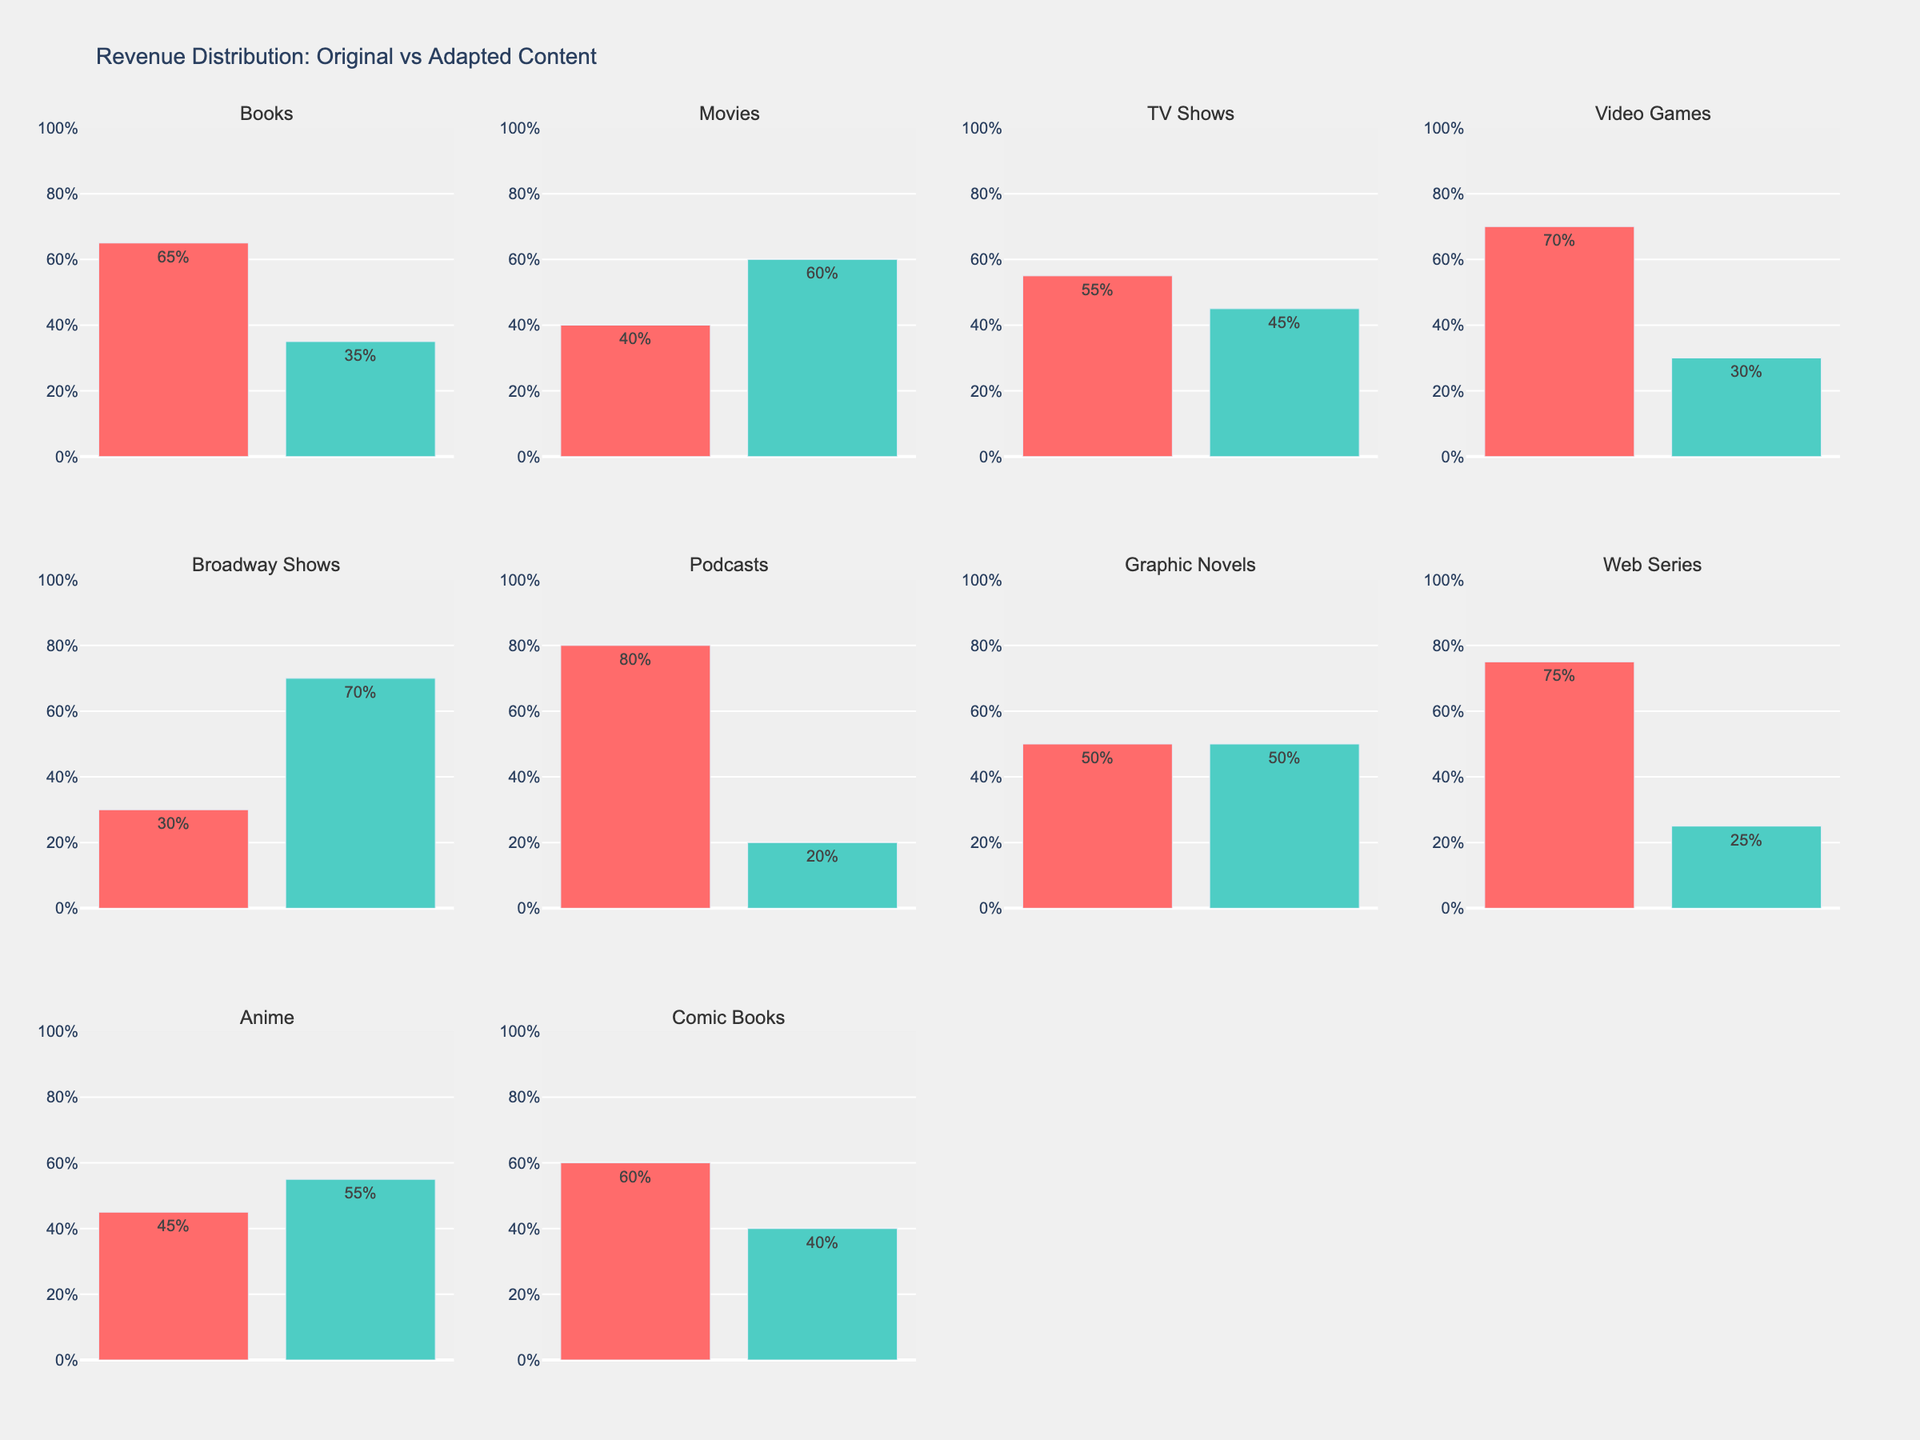what is the title of the figure? At the top of the figure, the large font text is the title: "Blocking Effectiveness Trends for Middle Blockers".
Answer: Blocking Effectiveness Trends for Middle Blockers How many players are analyzed in the figure? Each subplot title corresponds to a player; there are five subplot titles, indicating five players.
Answer: Five Which player has the highest blocking effectiveness in Week 15? Identify and compare the data points for Week 15 in each subplot. Milena Rasic has a blocking effectiveness of 0.94, which is the highest.
Answer: Milena Rasic For Chiaka Ogbogu, how much did her blocking effectiveness increase between Week 1 and Week 20? Subtract the blocking effectiveness in Week 1 (0.85) from Week 20 (0.98), the increase is 0.98 - 0.85 = 0.13.
Answer: 0.13 Which player shows a decrease in blocking effectiveness between any of the weeks? Examine the trends in each subplot. Foluke Akinradewo's blocking effectiveness decreases from Week 10 (0.93) to Week 15 (0.91).
Answer: Foluke Akinradewo Compare the blocking effectiveness of Robin de Kruijf and Eda Erdem in Week 10. Who has better effectiveness and by how much? Robin de Kruijf has an effectiveness of 0.87 in Week 10, while Eda Erdem has 0.90. The difference is 0.90 - 0.87 = 0.03. Eda Erdem has better effectiveness by 0.03.
Answer: Eda Erdem, by 0.03 Which player has the most consistent performance over the season? Consistency can be judged by the smallest range of effectiveness values across the weeks. Foluke Akinradewo ranges between 0.88 and 0.94, a difference of 0.06, which is the smallest among all players.
Answer: Foluke Akinradewo Is there a player whose blocking effectiveness always increased over the season? Examine each player's plot, checking if all subsequent values are higher than the previous ones. Chiaka Ogbogu's blocking effectiveness increased every observed week.
Answer: Chiaka Ogbogu What is the average blocking effectiveness for Eda Erdem over the season? Add the values for Eda Erdem: 0.82, 0.86, 0.90, 0.88, 0.92. Divide the sum by the number of weeks: (0.82 + 0.86 + 0.90 + 0.88 + 0.92)/5 = 0.876.
Answer: 0.876 